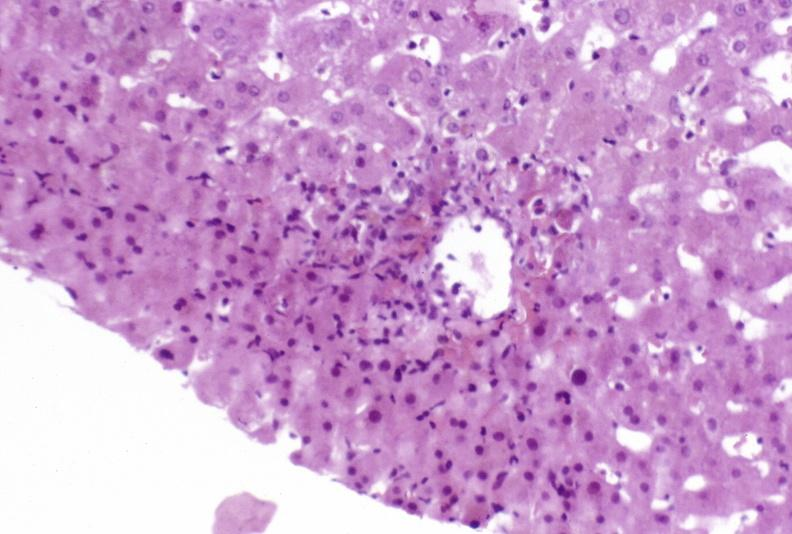what is present?
Answer the question using a single word or phrase. Liver 